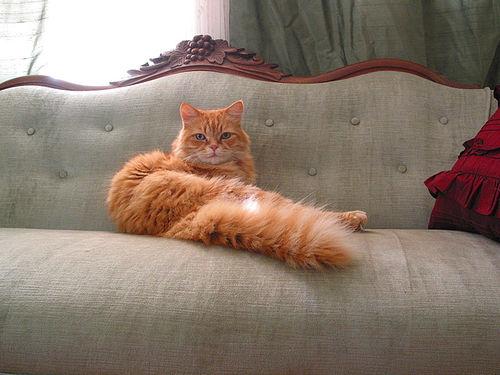Are the grapes edible?
Write a very short answer. No. What's the red item on the couch?
Keep it brief. Pillow. What style of furniture is the couch sitting on?
Write a very short answer. Couch. 